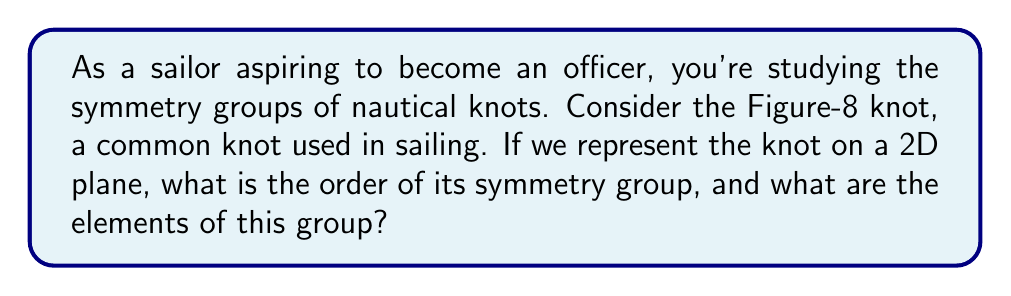Can you answer this question? Let's approach this step-by-step:

1) First, we need to visualize the Figure-8 knot in a 2D plane. It looks like this:

[asy]
unitsize(1cm);
path p = (0,0)..(1,1)..(2,0)..(1,-1)..cycle;
draw(p, linewidth(1));
draw((1,1)--(1,-1), linewidth(1));
</asy]

2) To determine the symmetry group, we need to identify all the symmetry operations that leave the knot unchanged.

3) Examining the knot, we can see that it has two types of symmetries:
   a) Rotational symmetry of 180° around the center point
   b) Reflection symmetry across two perpendicular axes

4) Let's define these symmetry operations:
   - $e$: identity operation (no change)
   - $r$: 180° rotation
   - $h$: horizontal reflection
   - $v$: vertical reflection

5) We can verify that these operations form a group:
   - They are closed under composition
   - The identity element $e$ exists
   - Each element has an inverse
   - The operations are associative

6) This group is isomorphic to the Klein four-group, $V_4$ or $C_2 \times C_2$.

7) The order of a group is the number of elements it contains. In this case, we have 4 elements: $\{e, r, h, v\}$.

Therefore, the order of the symmetry group is 4, and its elements are the identity, 180° rotation, and two reflections.
Answer: The symmetry group of the Figure-8 knot has order 4, and its elements are $\{e, r, h, v\}$, where $e$ is the identity, $r$ is 180° rotation, $h$ is horizontal reflection, and $v$ is vertical reflection. 